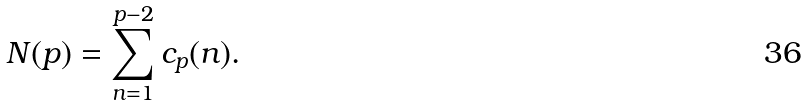<formula> <loc_0><loc_0><loc_500><loc_500>N ( p ) = \sum _ { n = 1 } ^ { p - 2 } c _ { p } ( n ) .</formula> 